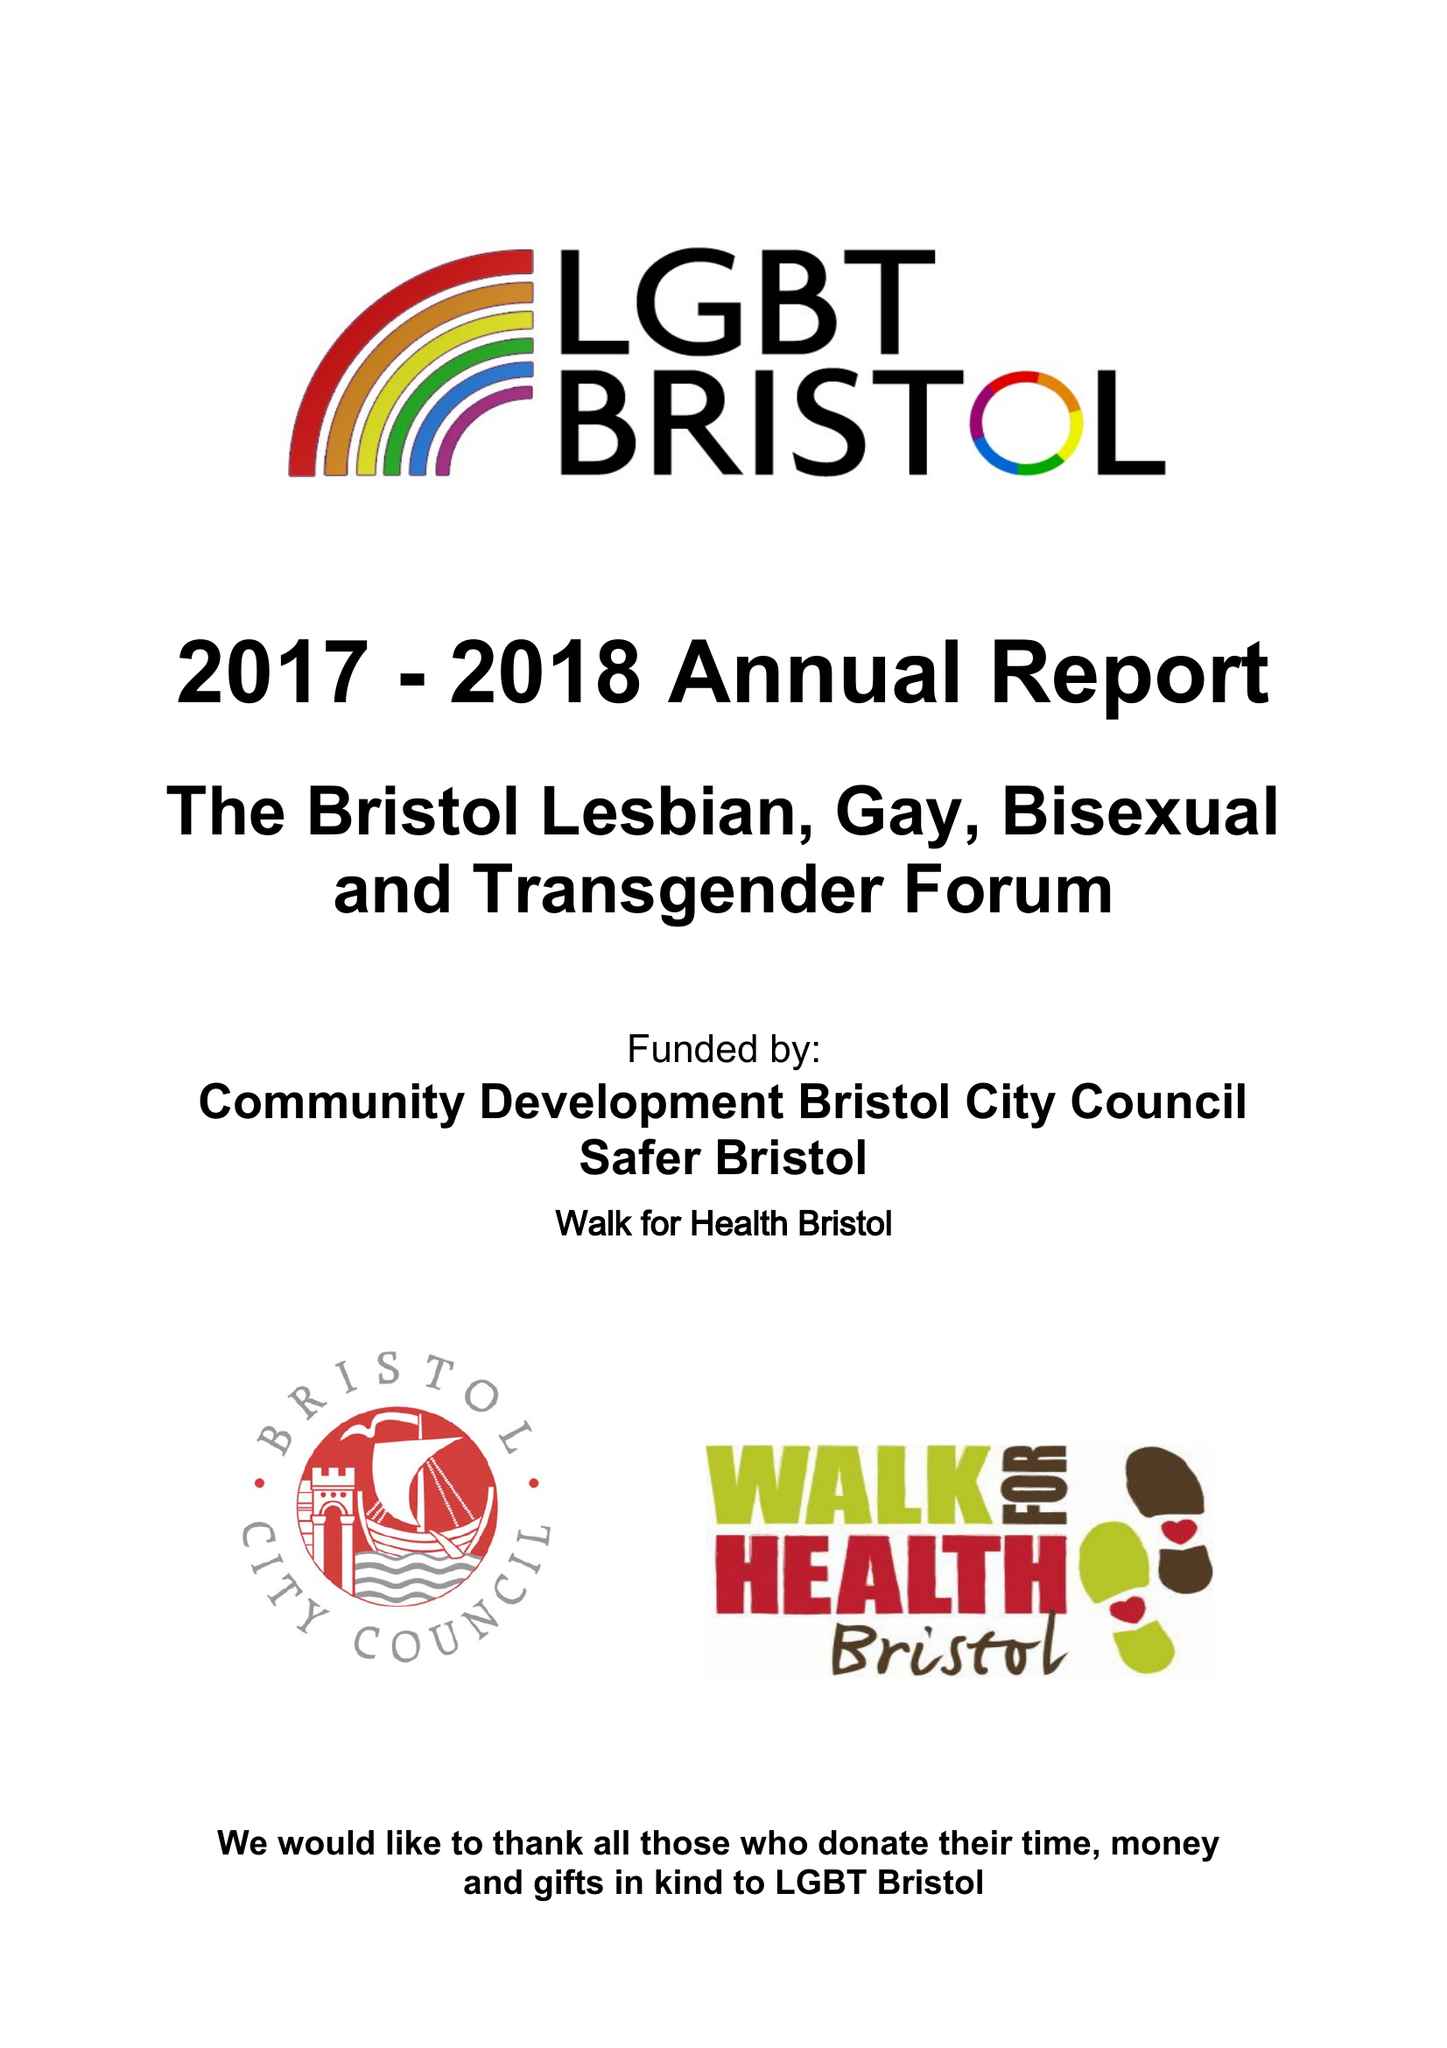What is the value for the income_annually_in_british_pounds?
Answer the question using a single word or phrase. 56632.00 